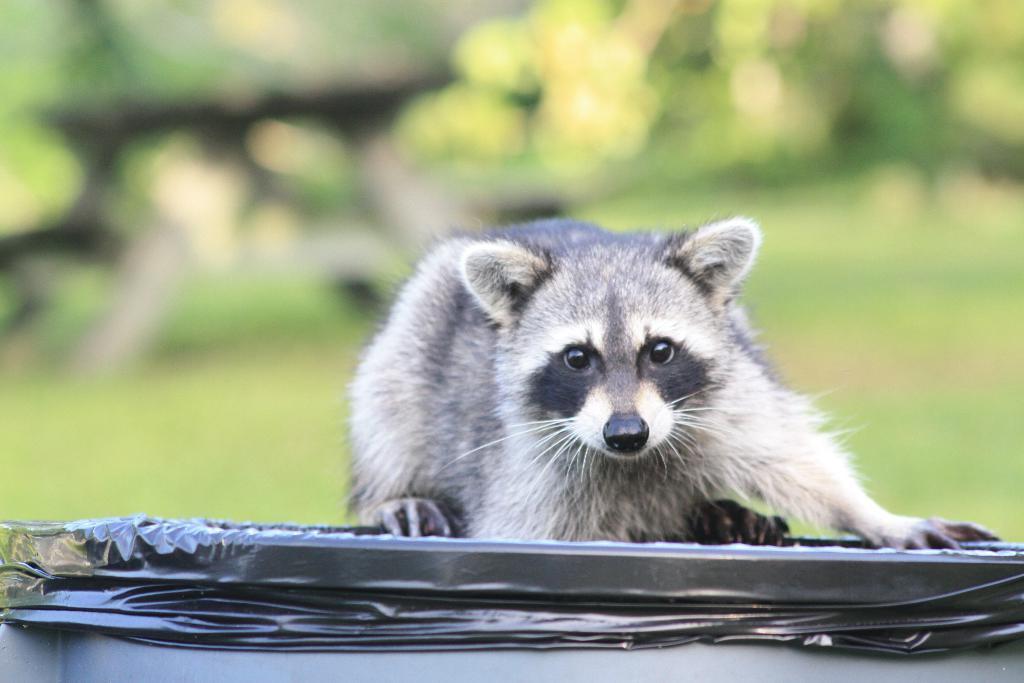Describe this image in one or two sentences. In the image in the center,we can see one raccoon,which is in black and white color on the black color object. In the background we can see trees. 